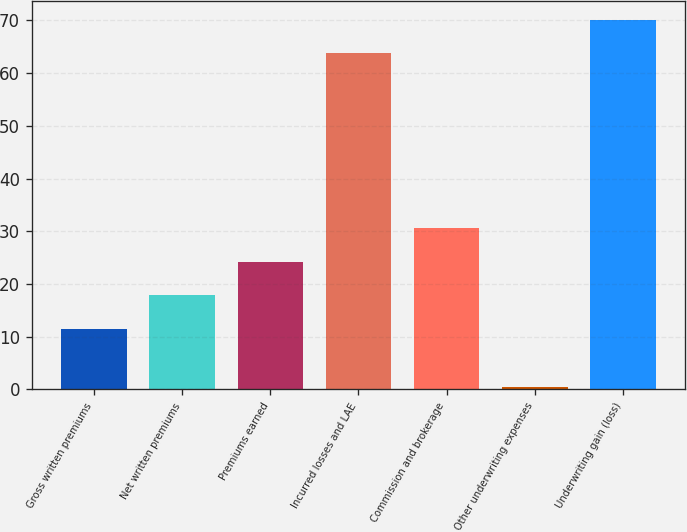<chart> <loc_0><loc_0><loc_500><loc_500><bar_chart><fcel>Gross written premiums<fcel>Net written premiums<fcel>Premiums earned<fcel>Incurred losses and LAE<fcel>Commission and brokerage<fcel>Other underwriting expenses<fcel>Underwriting gain (loss)<nl><fcel>11.5<fcel>17.86<fcel>24.22<fcel>63.8<fcel>30.58<fcel>0.4<fcel>70.16<nl></chart> 